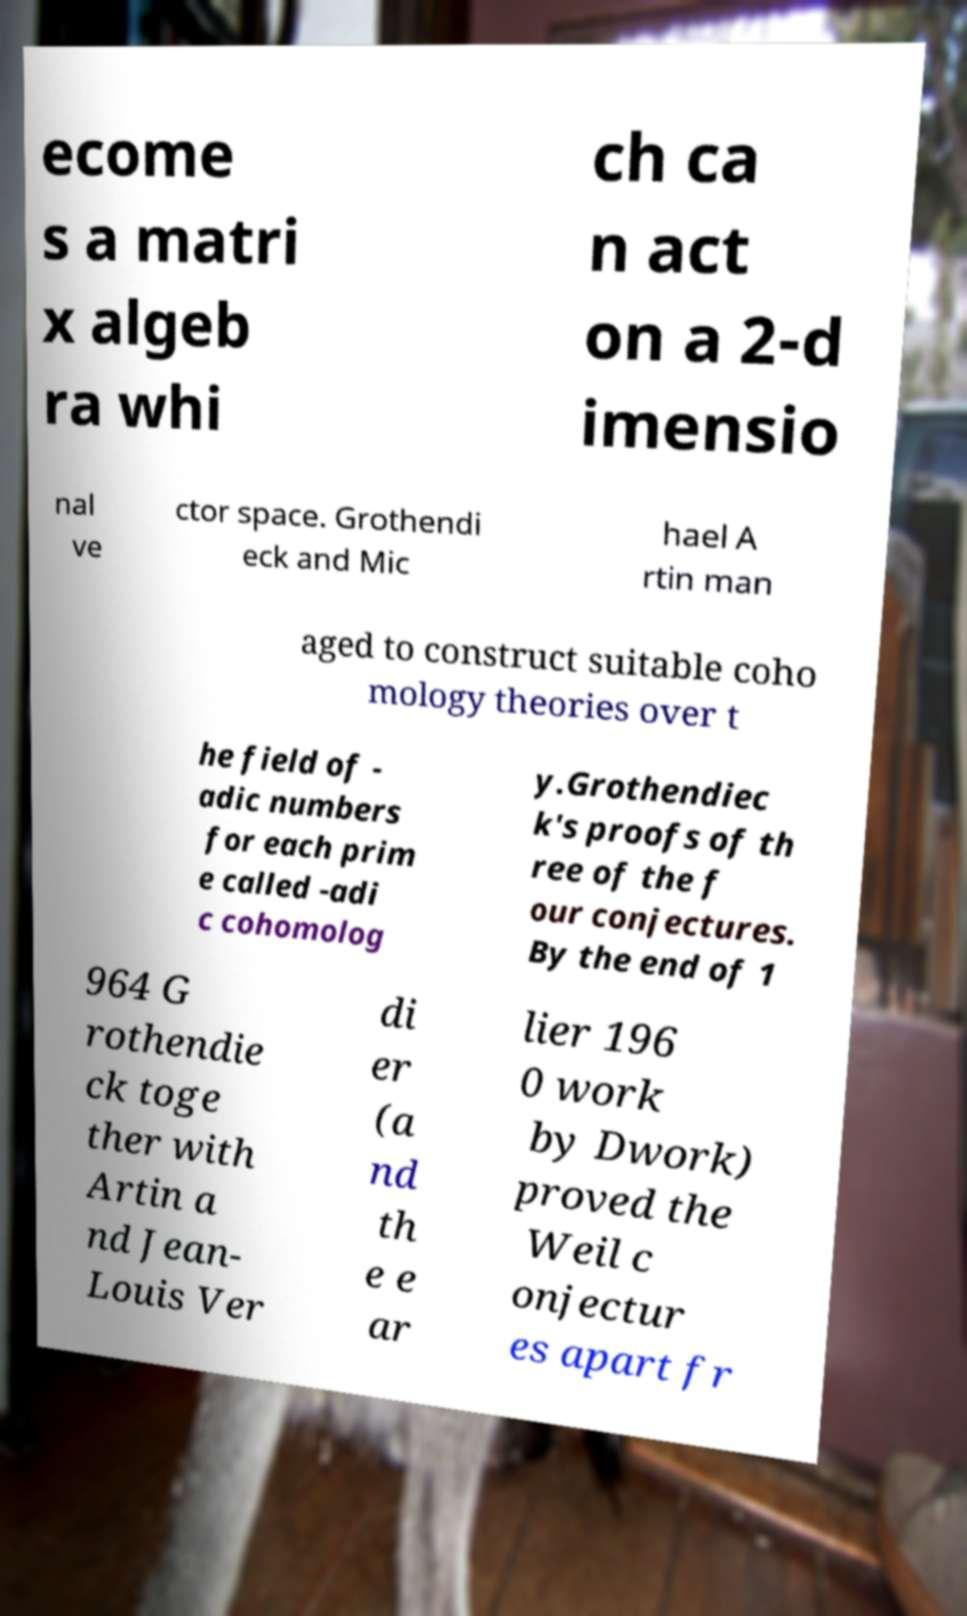Please read and relay the text visible in this image. What does it say? ecome s a matri x algeb ra whi ch ca n act on a 2-d imensio nal ve ctor space. Grothendi eck and Mic hael A rtin man aged to construct suitable coho mology theories over t he field of - adic numbers for each prim e called -adi c cohomolog y.Grothendiec k's proofs of th ree of the f our conjectures. By the end of 1 964 G rothendie ck toge ther with Artin a nd Jean- Louis Ver di er (a nd th e e ar lier 196 0 work by Dwork) proved the Weil c onjectur es apart fr 